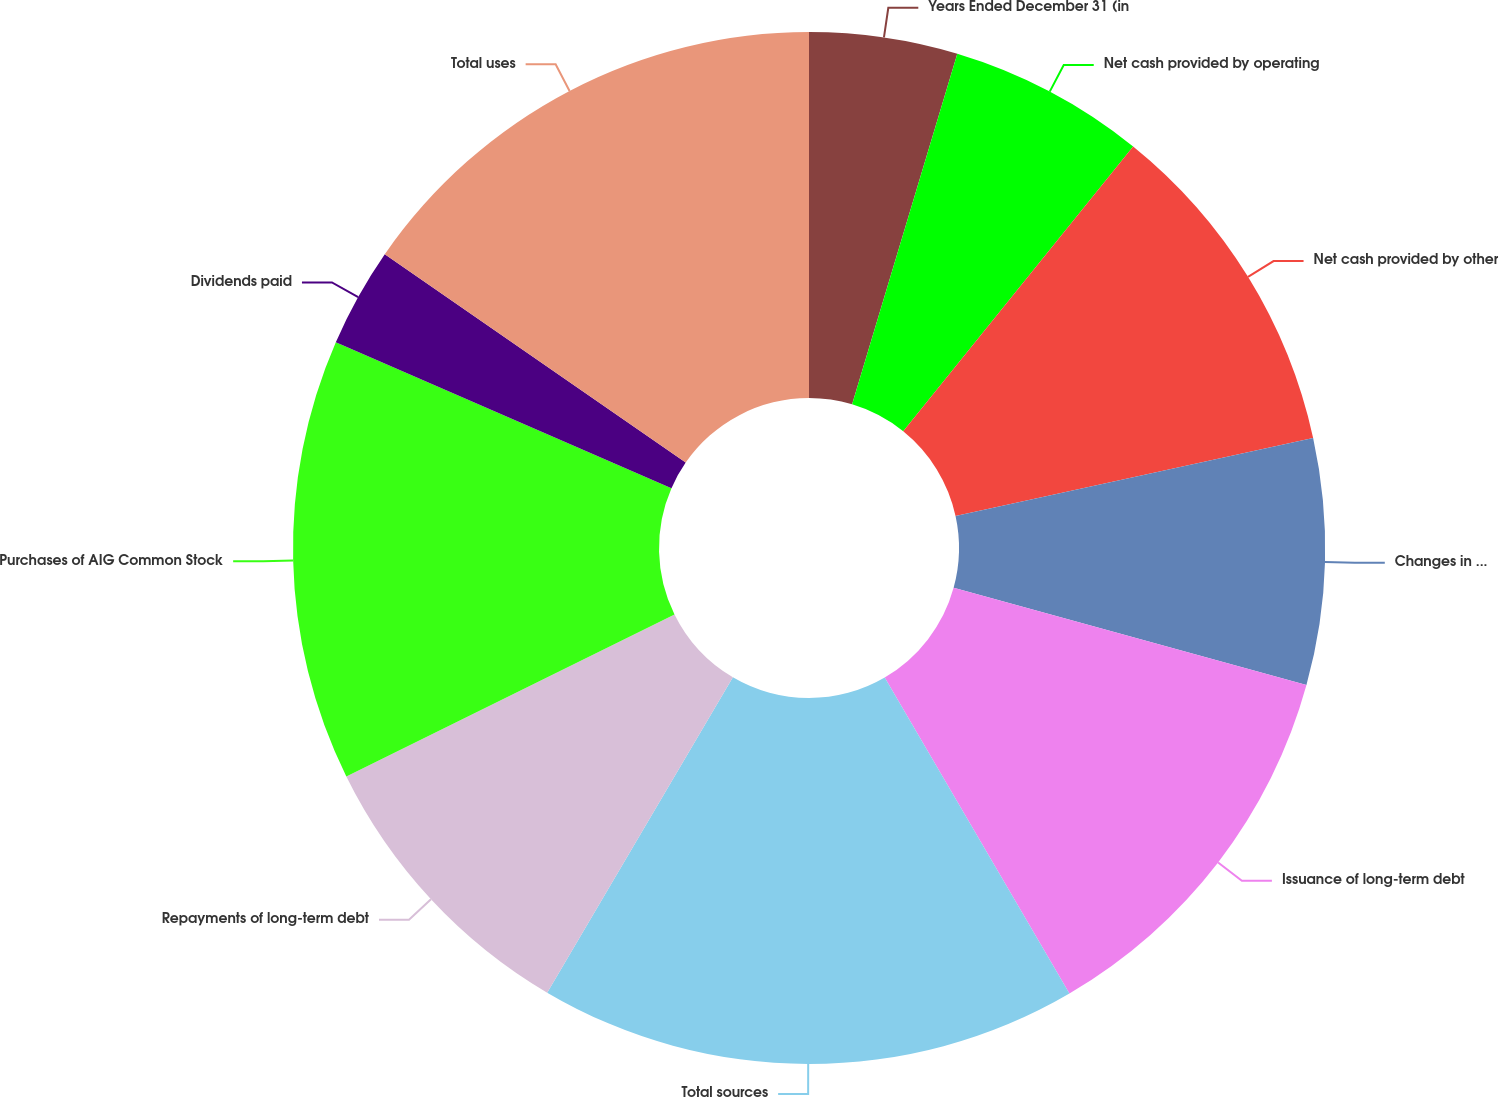<chart> <loc_0><loc_0><loc_500><loc_500><pie_chart><fcel>Years Ended December 31 (in<fcel>Net cash provided by operating<fcel>Net cash provided by other<fcel>Changes in policyholder<fcel>Issuance of long-term debt<fcel>Total sources<fcel>Repayments of long-term debt<fcel>Purchases of AIG Common Stock<fcel>Dividends paid<fcel>Total uses<nl><fcel>4.64%<fcel>6.17%<fcel>10.77%<fcel>7.7%<fcel>12.3%<fcel>16.89%<fcel>9.23%<fcel>13.83%<fcel>3.11%<fcel>15.36%<nl></chart> 